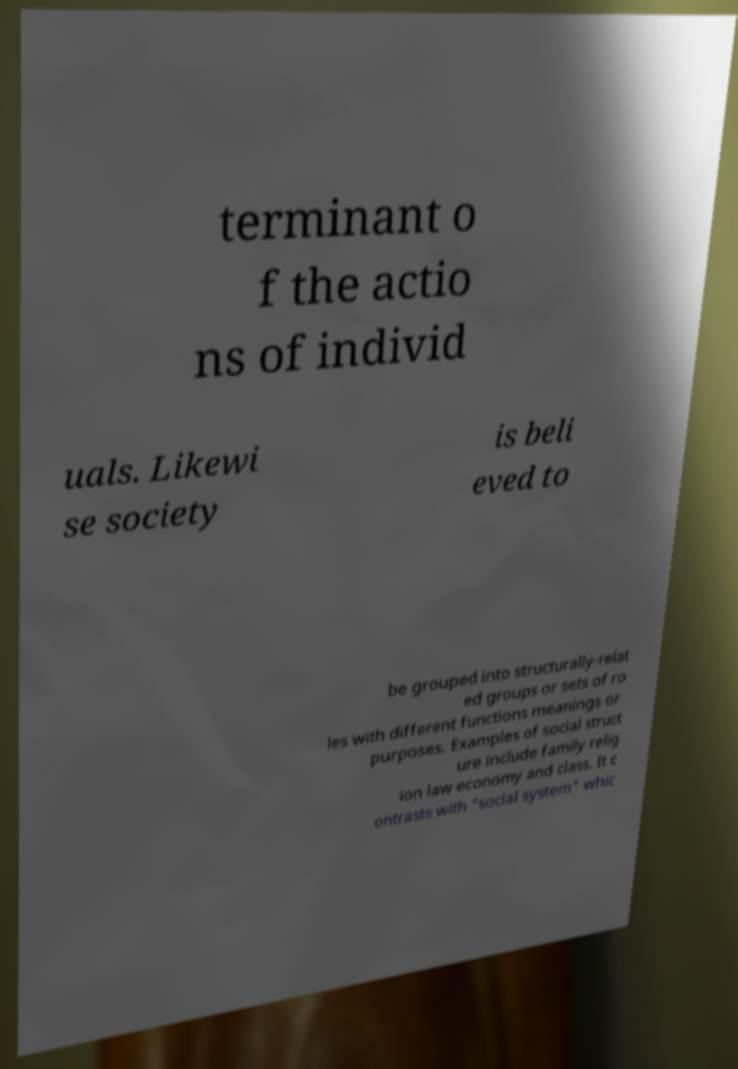Please read and relay the text visible in this image. What does it say? terminant o f the actio ns of individ uals. Likewi se society is beli eved to be grouped into structurally-relat ed groups or sets of ro les with different functions meanings or purposes. Examples of social struct ure include family relig ion law economy and class. It c ontrasts with "social system" whic 